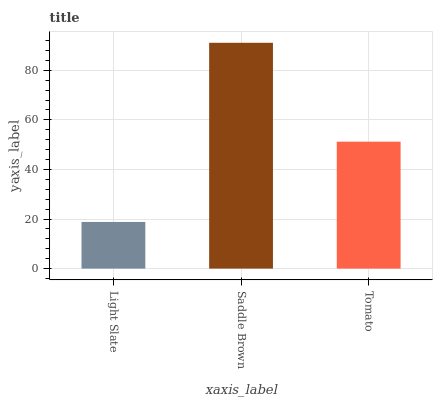Is Light Slate the minimum?
Answer yes or no. Yes. Is Saddle Brown the maximum?
Answer yes or no. Yes. Is Tomato the minimum?
Answer yes or no. No. Is Tomato the maximum?
Answer yes or no. No. Is Saddle Brown greater than Tomato?
Answer yes or no. Yes. Is Tomato less than Saddle Brown?
Answer yes or no. Yes. Is Tomato greater than Saddle Brown?
Answer yes or no. No. Is Saddle Brown less than Tomato?
Answer yes or no. No. Is Tomato the high median?
Answer yes or no. Yes. Is Tomato the low median?
Answer yes or no. Yes. Is Light Slate the high median?
Answer yes or no. No. Is Saddle Brown the low median?
Answer yes or no. No. 